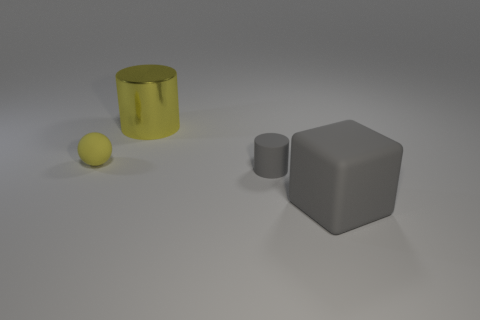What shape is the big shiny object that is the same color as the tiny rubber ball?
Offer a very short reply. Cylinder. What material is the big gray cube?
Give a very brief answer. Rubber. How many other objects are there of the same material as the big yellow cylinder?
Offer a very short reply. 0. What number of small gray rubber things are there?
Make the answer very short. 1. There is a tiny object that is the same shape as the large metal object; what is its material?
Make the answer very short. Rubber. Is the large thing that is behind the small gray object made of the same material as the gray cylinder?
Your answer should be compact. No. Is the number of tiny balls that are right of the gray block greater than the number of large yellow shiny cylinders left of the big yellow shiny cylinder?
Offer a very short reply. No. The rubber cylinder has what size?
Provide a short and direct response. Small. What shape is the tiny yellow thing that is the same material as the cube?
Offer a very short reply. Sphere. Is the shape of the yellow object to the right of the tiny rubber sphere the same as  the small yellow matte thing?
Your answer should be compact. No. 